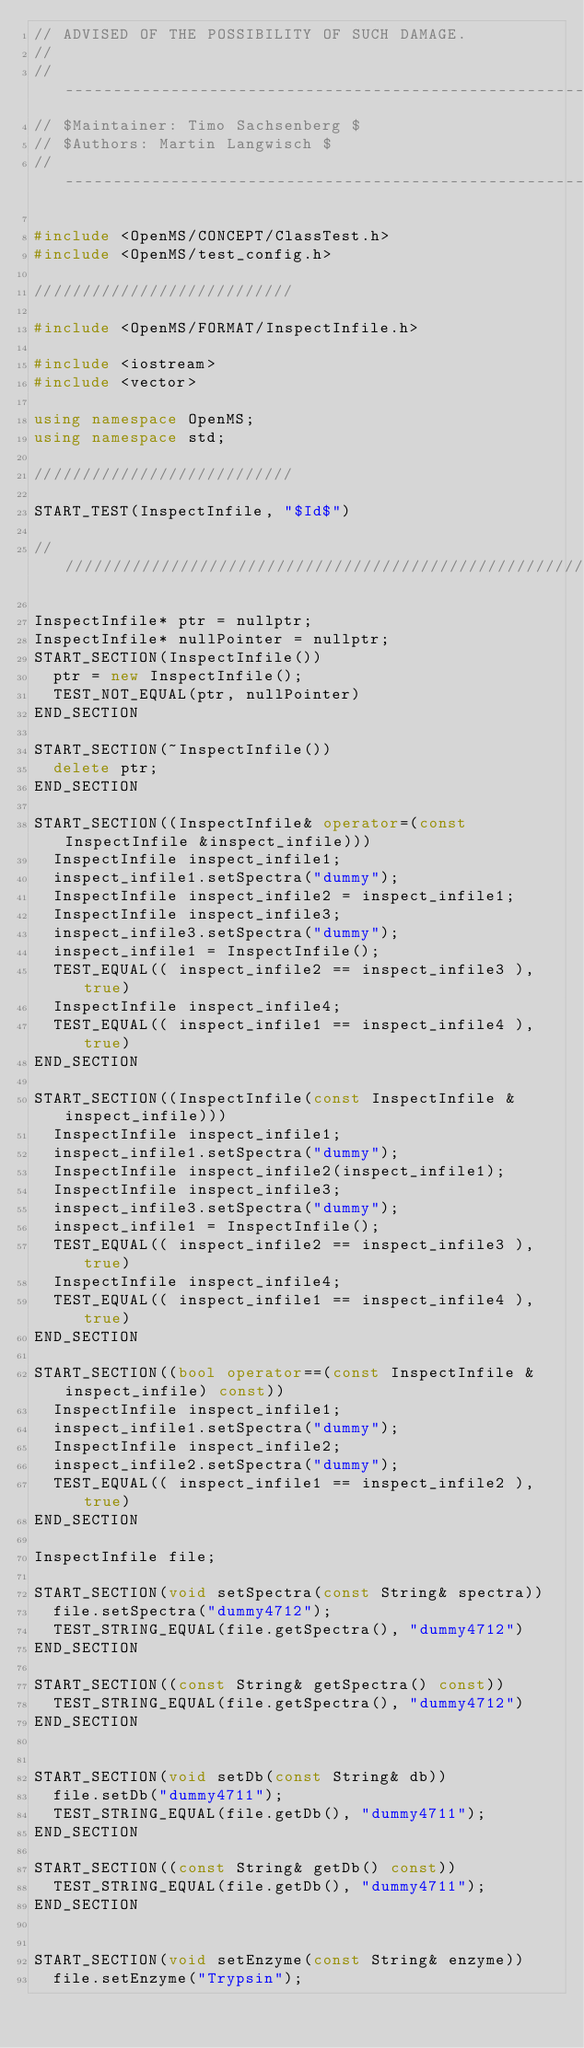Convert code to text. <code><loc_0><loc_0><loc_500><loc_500><_C++_>// ADVISED OF THE POSSIBILITY OF SUCH DAMAGE.
// 
// --------------------------------------------------------------------------
// $Maintainer: Timo Sachsenberg $
// $Authors: Martin Langwisch $
// --------------------------------------------------------------------------

#include <OpenMS/CONCEPT/ClassTest.h>
#include <OpenMS/test_config.h>

///////////////////////////

#include <OpenMS/FORMAT/InspectInfile.h>

#include <iostream>
#include <vector>

using namespace OpenMS;
using namespace std;

///////////////////////////

START_TEST(InspectInfile, "$Id$")

/////////////////////////////////////////////////////////////

InspectInfile* ptr = nullptr;
InspectInfile* nullPointer = nullptr;
START_SECTION(InspectInfile())
	ptr = new InspectInfile();
	TEST_NOT_EQUAL(ptr, nullPointer)
END_SECTION

START_SECTION(~InspectInfile())
	delete ptr;
END_SECTION

START_SECTION((InspectInfile& operator=(const InspectInfile &inspect_infile)))
	InspectInfile inspect_infile1;
	inspect_infile1.setSpectra("dummy");
	InspectInfile inspect_infile2 = inspect_infile1;
	InspectInfile inspect_infile3;
	inspect_infile3.setSpectra("dummy");
	inspect_infile1 = InspectInfile();
	TEST_EQUAL(( inspect_infile2 == inspect_infile3 ), true)
	InspectInfile inspect_infile4;
	TEST_EQUAL(( inspect_infile1 == inspect_infile4 ), true)
END_SECTION

START_SECTION((InspectInfile(const InspectInfile &inspect_infile)))
	InspectInfile inspect_infile1;
	inspect_infile1.setSpectra("dummy");
	InspectInfile inspect_infile2(inspect_infile1);
	InspectInfile inspect_infile3;
	inspect_infile3.setSpectra("dummy");
	inspect_infile1 = InspectInfile();
	TEST_EQUAL(( inspect_infile2 == inspect_infile3 ), true)
	InspectInfile inspect_infile4;
	TEST_EQUAL(( inspect_infile1 == inspect_infile4 ), true)
END_SECTION

START_SECTION((bool operator==(const InspectInfile &inspect_infile) const))
	InspectInfile inspect_infile1;
	inspect_infile1.setSpectra("dummy");
	InspectInfile inspect_infile2;
	inspect_infile2.setSpectra("dummy");
	TEST_EQUAL(( inspect_infile1 == inspect_infile2 ), true)
END_SECTION

InspectInfile file;

START_SECTION(void setSpectra(const String& spectra))
	file.setSpectra("dummy4712");
	TEST_STRING_EQUAL(file.getSpectra(), "dummy4712")
END_SECTION

START_SECTION((const String& getSpectra() const))
	TEST_STRING_EQUAL(file.getSpectra(), "dummy4712")
END_SECTION


START_SECTION(void setDb(const String& db))
	file.setDb("dummy4711");
	TEST_STRING_EQUAL(file.getDb(), "dummy4711");
END_SECTION

START_SECTION((const String& getDb() const))
	TEST_STRING_EQUAL(file.getDb(), "dummy4711");
END_SECTION


START_SECTION(void setEnzyme(const String& enzyme))
	file.setEnzyme("Trypsin");</code> 